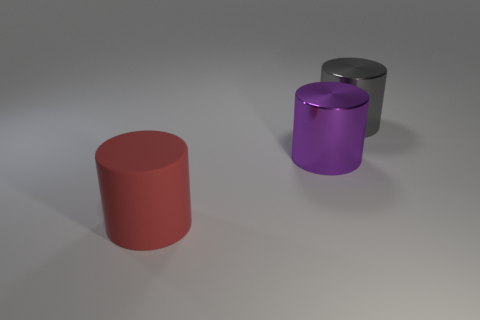How many gray shiny objects have the same shape as the big purple object? There is one gray shiny object that shares the same cylindrical shape as the large purple object. This cylindrical shape is characterized by its circular base and elongated straight sides. 